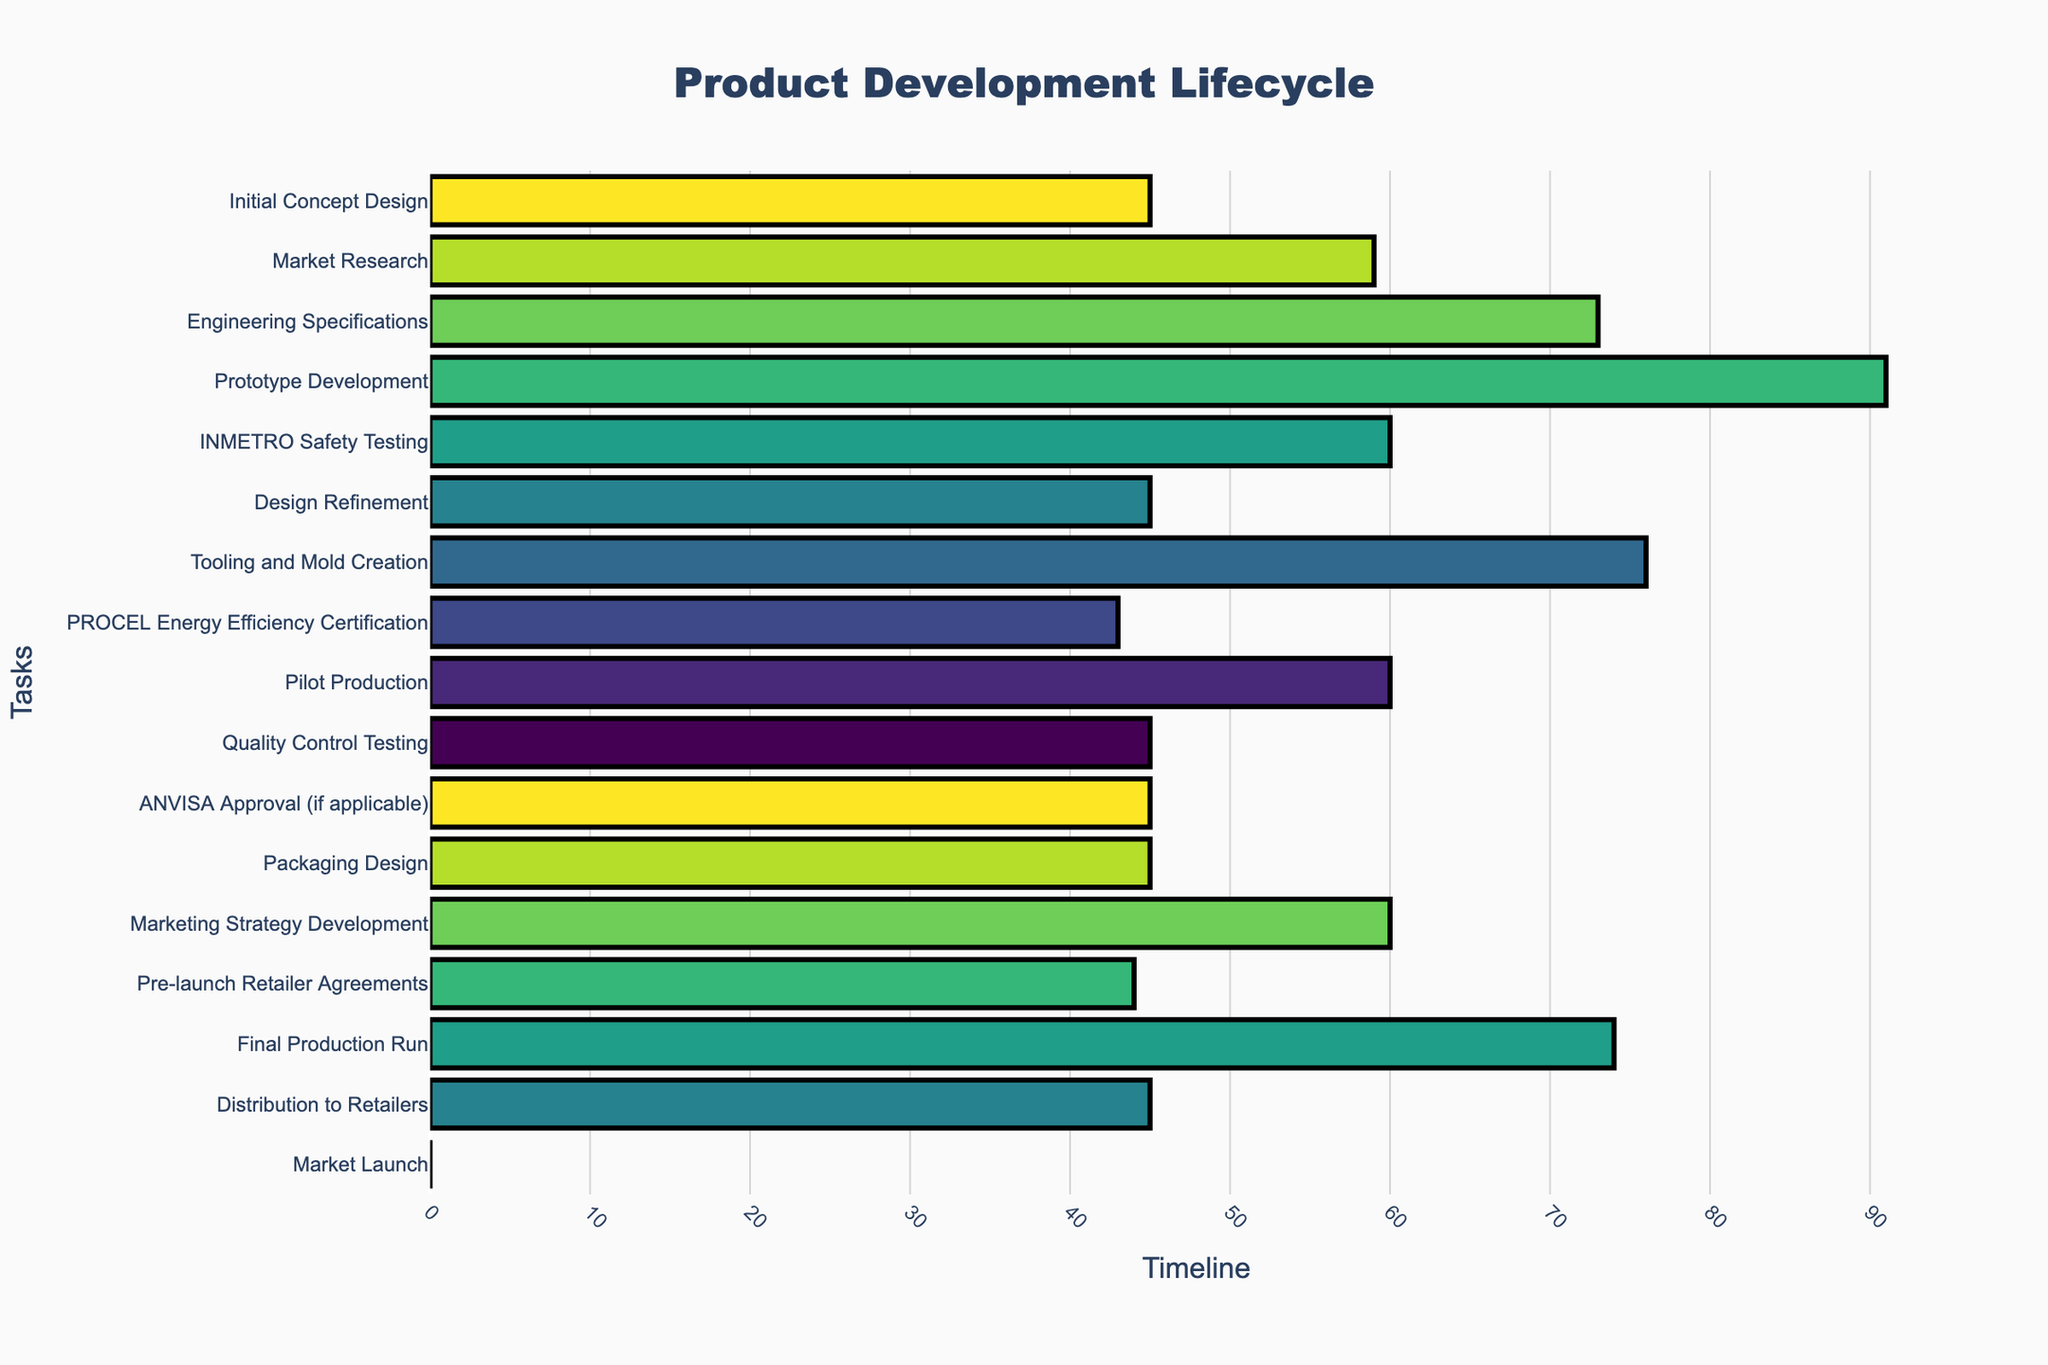What is the title of the Gantt chart? The title of the Gantt chart is typically displayed at the top of the figure, often in a large and bold font. To find the title, look at the center-top of the chart.
Answer: Product Development Lifecycle Which task duration appears to be the longest? To determine the task with the longest duration, look at the horizontal bars representing each task and compare their lengths. The longest bar represents the task with the longest duration.
Answer: Final Production Run During which months does the "Prototype Development" stage take place? Locate the "Prototype Development" task on the y-axis and follow the horizontal bar corresponding to this task to see its start and end dates on the x-axis.
Answer: May to July 2023 Which stages occur in parallel with the "Prototype Development"? Find the horizontal bar for "Prototype Development," and identify other bars that align vertically within the same time frame.
Answer: Engineering Specifications and INMETRO Safety Testing How many tasks are scheduled to end in 2024? Look at the end dates on the x-axis and count the number of bars that have their end points within the year 2024.
Answer: 8 What is the sequence of tasks leading up to "Marketing Strategy Development"? Identify the task "Marketing Strategy Development" and trace back to its immediate predecessor, continuing until you reach the first task. The tasks must be in chronological order.
Answer: Packaging Design → ANVISA Approval → Quality Control Testing → Pilot Production Which regulatory approval stages are included in the product development lifecycle? Look for tasks related to regulatory approval by identifying terms like "testing" and "approval" in the task names.
Answer: INMETRO Safety Testing, PROCEL Energy Efficiency Certification, ANVISA Approval Between which months does the "Tooling and Mold Creation" stage take place? Locate the "Tooling and Mold Creation" task on the y-axis and follow its horizontal bar to read the start and end dates on the x-axis.
Answer: November 2023 to January 2024 What tasks overlap with the "Market Research" phase? Find the "Market Research" task and look for other tasks with bars aligning vertically within the same time frame.
Answer: Initial Concept Design, Engineering Specifications In which quarter of 2024 does the "Pilot Production" phase start? Identify the start date of the "Pilot Production" task and determine the quarter by dividing the year into four three-month periods.
Answer: Q1 2024 